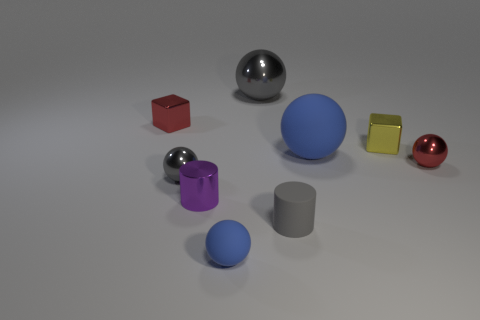What number of other objects are the same color as the rubber cylinder?
Your answer should be compact. 2. There is a tiny red object left of the ball to the right of the tiny shiny block that is to the right of the red shiny cube; what is it made of?
Your answer should be compact. Metal. How many cubes are either blue objects or red things?
Keep it short and to the point. 1. There is a small metal ball to the left of the tiny metallic cube in front of the red cube; what number of tiny gray objects are in front of it?
Keep it short and to the point. 1. Is the shape of the purple metallic object the same as the large matte thing?
Provide a succinct answer. No. Do the red object that is to the left of the small red sphere and the big thing that is in front of the red shiny block have the same material?
Your response must be concise. No. What number of objects are tiny red spheres in front of the big gray metallic object or blue balls that are in front of the large rubber ball?
Offer a very short reply. 2. How many tiny yellow metallic balls are there?
Your answer should be compact. 0. Are there any shiny balls of the same size as the red metallic block?
Your answer should be very brief. Yes. Is the material of the purple thing the same as the cube that is right of the big blue thing?
Make the answer very short. Yes. 